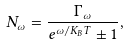<formula> <loc_0><loc_0><loc_500><loc_500>N _ { \omega } = \frac { \Gamma _ { \omega } } { e ^ { \omega / K _ { B } T } \pm 1 } ,</formula> 